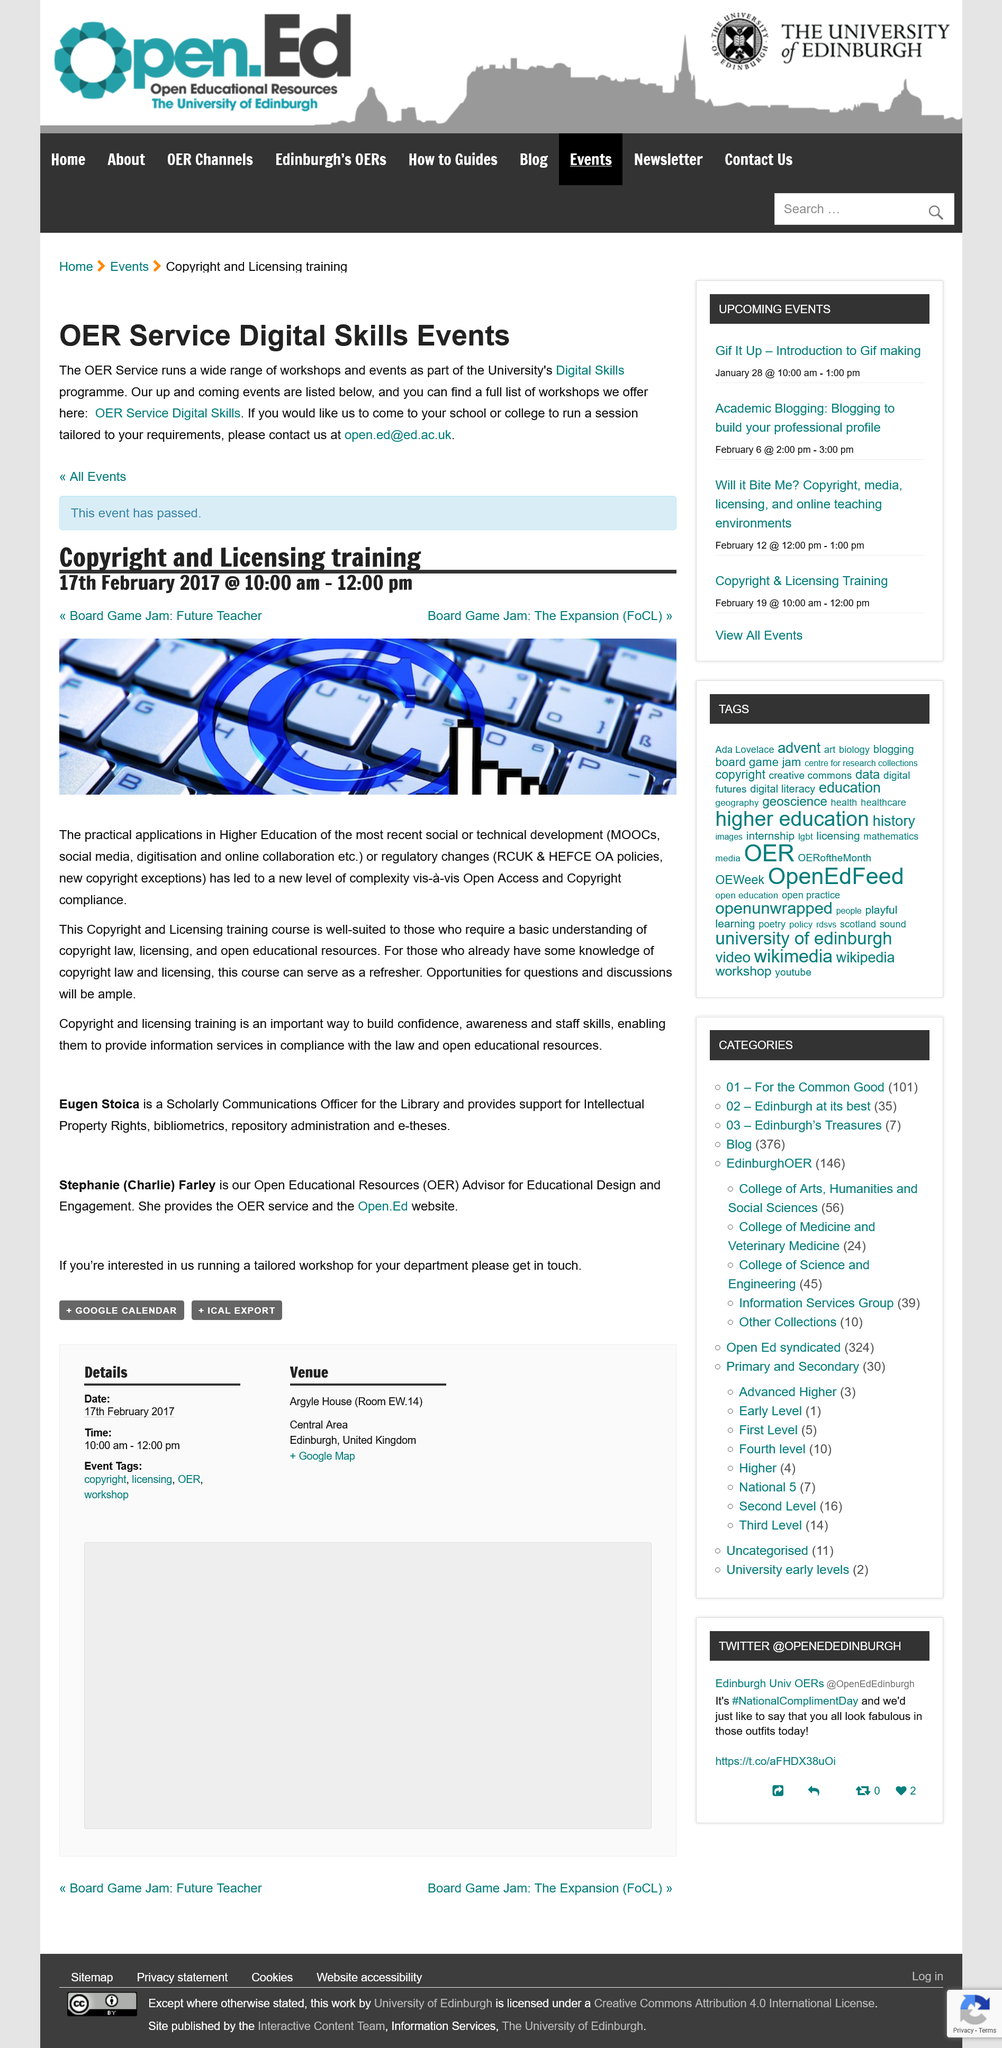Mention a couple of crucial points in this snapshot. The Copyright and Licensing training course is aimed at individuals who seek a fundamental understanding of copyright law, licensing, and open educational resources. The Copyright and Licensing Training event is scheduled to take place on February 17th, 2017. The Copyright and Licensing Training event has concluded successfully. The Copyright and Licensing Training event is two hours long. Eugen Stoica is a Scholarly Communications Officer for the Library at Harvard University. 